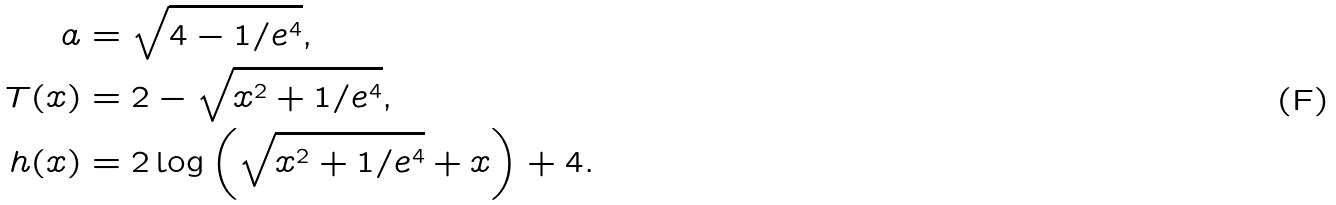Convert formula to latex. <formula><loc_0><loc_0><loc_500><loc_500>a & = \sqrt { 4 - 1 / e ^ { 4 } } , \\ T ( x ) & = 2 - \sqrt { x ^ { 2 } + 1 / e ^ { 4 } } , \\ h ( x ) & = 2 \log \left ( \sqrt { x ^ { 2 } + 1 / e ^ { 4 } } + x \right ) + 4 .</formula> 